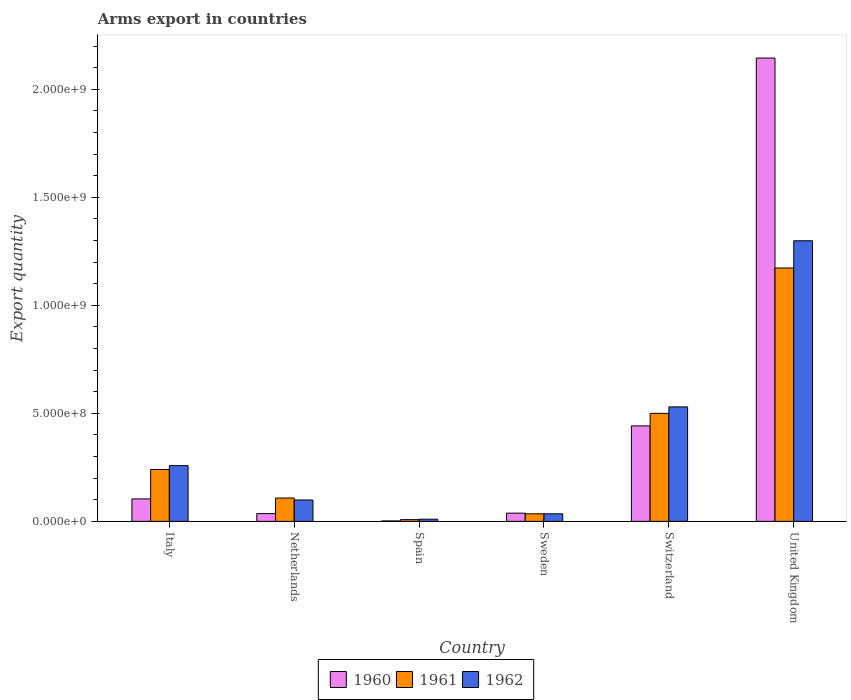How many different coloured bars are there?
Your answer should be very brief. 3. Are the number of bars per tick equal to the number of legend labels?
Offer a terse response. Yes. How many bars are there on the 3rd tick from the left?
Make the answer very short. 3. In how many cases, is the number of bars for a given country not equal to the number of legend labels?
Keep it short and to the point. 0. Across all countries, what is the maximum total arms export in 1960?
Your response must be concise. 2.14e+09. Across all countries, what is the minimum total arms export in 1960?
Keep it short and to the point. 2.00e+06. What is the total total arms export in 1961 in the graph?
Your answer should be very brief. 2.06e+09. What is the difference between the total arms export in 1962 in Netherlands and that in United Kingdom?
Your answer should be compact. -1.20e+09. What is the difference between the total arms export in 1961 in Netherlands and the total arms export in 1960 in Switzerland?
Make the answer very short. -3.34e+08. What is the average total arms export in 1962 per country?
Your response must be concise. 3.72e+08. What is the difference between the total arms export of/in 1960 and total arms export of/in 1961 in Italy?
Your answer should be very brief. -1.36e+08. What is the ratio of the total arms export in 1962 in Italy to that in Spain?
Your answer should be very brief. 25.8. Is the difference between the total arms export in 1960 in Netherlands and United Kingdom greater than the difference between the total arms export in 1961 in Netherlands and United Kingdom?
Your answer should be very brief. No. What is the difference between the highest and the second highest total arms export in 1962?
Your answer should be compact. 1.04e+09. What is the difference between the highest and the lowest total arms export in 1961?
Your answer should be compact. 1.16e+09. In how many countries, is the total arms export in 1960 greater than the average total arms export in 1960 taken over all countries?
Your response must be concise. 1. What does the 2nd bar from the left in Sweden represents?
Make the answer very short. 1961. Are all the bars in the graph horizontal?
Offer a terse response. No. What is the difference between two consecutive major ticks on the Y-axis?
Keep it short and to the point. 5.00e+08. Does the graph contain any zero values?
Keep it short and to the point. No. How many legend labels are there?
Ensure brevity in your answer.  3. How are the legend labels stacked?
Your response must be concise. Horizontal. What is the title of the graph?
Provide a succinct answer. Arms export in countries. What is the label or title of the X-axis?
Make the answer very short. Country. What is the label or title of the Y-axis?
Make the answer very short. Export quantity. What is the Export quantity of 1960 in Italy?
Provide a succinct answer. 1.04e+08. What is the Export quantity in 1961 in Italy?
Provide a short and direct response. 2.40e+08. What is the Export quantity of 1962 in Italy?
Make the answer very short. 2.58e+08. What is the Export quantity in 1960 in Netherlands?
Provide a short and direct response. 3.60e+07. What is the Export quantity of 1961 in Netherlands?
Your answer should be very brief. 1.08e+08. What is the Export quantity in 1962 in Netherlands?
Your response must be concise. 9.90e+07. What is the Export quantity of 1960 in Spain?
Give a very brief answer. 2.00e+06. What is the Export quantity in 1961 in Spain?
Give a very brief answer. 8.00e+06. What is the Export quantity of 1960 in Sweden?
Your response must be concise. 3.80e+07. What is the Export quantity in 1961 in Sweden?
Provide a short and direct response. 3.50e+07. What is the Export quantity in 1962 in Sweden?
Your response must be concise. 3.50e+07. What is the Export quantity of 1960 in Switzerland?
Your response must be concise. 4.42e+08. What is the Export quantity of 1962 in Switzerland?
Provide a succinct answer. 5.30e+08. What is the Export quantity in 1960 in United Kingdom?
Make the answer very short. 2.14e+09. What is the Export quantity of 1961 in United Kingdom?
Keep it short and to the point. 1.17e+09. What is the Export quantity in 1962 in United Kingdom?
Give a very brief answer. 1.30e+09. Across all countries, what is the maximum Export quantity in 1960?
Your answer should be compact. 2.14e+09. Across all countries, what is the maximum Export quantity of 1961?
Your answer should be very brief. 1.17e+09. Across all countries, what is the maximum Export quantity of 1962?
Provide a succinct answer. 1.30e+09. Across all countries, what is the minimum Export quantity in 1961?
Offer a terse response. 8.00e+06. What is the total Export quantity of 1960 in the graph?
Ensure brevity in your answer.  2.77e+09. What is the total Export quantity in 1961 in the graph?
Your answer should be very brief. 2.06e+09. What is the total Export quantity of 1962 in the graph?
Offer a very short reply. 2.23e+09. What is the difference between the Export quantity in 1960 in Italy and that in Netherlands?
Offer a very short reply. 6.80e+07. What is the difference between the Export quantity in 1961 in Italy and that in Netherlands?
Give a very brief answer. 1.32e+08. What is the difference between the Export quantity of 1962 in Italy and that in Netherlands?
Your response must be concise. 1.59e+08. What is the difference between the Export quantity of 1960 in Italy and that in Spain?
Give a very brief answer. 1.02e+08. What is the difference between the Export quantity in 1961 in Italy and that in Spain?
Provide a succinct answer. 2.32e+08. What is the difference between the Export quantity in 1962 in Italy and that in Spain?
Give a very brief answer. 2.48e+08. What is the difference between the Export quantity of 1960 in Italy and that in Sweden?
Keep it short and to the point. 6.60e+07. What is the difference between the Export quantity in 1961 in Italy and that in Sweden?
Your response must be concise. 2.05e+08. What is the difference between the Export quantity in 1962 in Italy and that in Sweden?
Your answer should be compact. 2.23e+08. What is the difference between the Export quantity in 1960 in Italy and that in Switzerland?
Your response must be concise. -3.38e+08. What is the difference between the Export quantity in 1961 in Italy and that in Switzerland?
Make the answer very short. -2.60e+08. What is the difference between the Export quantity of 1962 in Italy and that in Switzerland?
Ensure brevity in your answer.  -2.72e+08. What is the difference between the Export quantity in 1960 in Italy and that in United Kingdom?
Provide a short and direct response. -2.04e+09. What is the difference between the Export quantity of 1961 in Italy and that in United Kingdom?
Your answer should be very brief. -9.33e+08. What is the difference between the Export quantity of 1962 in Italy and that in United Kingdom?
Give a very brief answer. -1.04e+09. What is the difference between the Export quantity in 1960 in Netherlands and that in Spain?
Keep it short and to the point. 3.40e+07. What is the difference between the Export quantity of 1962 in Netherlands and that in Spain?
Offer a terse response. 8.90e+07. What is the difference between the Export quantity of 1960 in Netherlands and that in Sweden?
Your answer should be very brief. -2.00e+06. What is the difference between the Export quantity in 1961 in Netherlands and that in Sweden?
Your answer should be very brief. 7.30e+07. What is the difference between the Export quantity of 1962 in Netherlands and that in Sweden?
Make the answer very short. 6.40e+07. What is the difference between the Export quantity of 1960 in Netherlands and that in Switzerland?
Give a very brief answer. -4.06e+08. What is the difference between the Export quantity in 1961 in Netherlands and that in Switzerland?
Your answer should be compact. -3.92e+08. What is the difference between the Export quantity in 1962 in Netherlands and that in Switzerland?
Give a very brief answer. -4.31e+08. What is the difference between the Export quantity in 1960 in Netherlands and that in United Kingdom?
Provide a succinct answer. -2.11e+09. What is the difference between the Export quantity in 1961 in Netherlands and that in United Kingdom?
Offer a very short reply. -1.06e+09. What is the difference between the Export quantity of 1962 in Netherlands and that in United Kingdom?
Make the answer very short. -1.20e+09. What is the difference between the Export quantity of 1960 in Spain and that in Sweden?
Give a very brief answer. -3.60e+07. What is the difference between the Export quantity in 1961 in Spain and that in Sweden?
Make the answer very short. -2.70e+07. What is the difference between the Export quantity in 1962 in Spain and that in Sweden?
Your answer should be compact. -2.50e+07. What is the difference between the Export quantity of 1960 in Spain and that in Switzerland?
Offer a terse response. -4.40e+08. What is the difference between the Export quantity of 1961 in Spain and that in Switzerland?
Offer a very short reply. -4.92e+08. What is the difference between the Export quantity of 1962 in Spain and that in Switzerland?
Make the answer very short. -5.20e+08. What is the difference between the Export quantity of 1960 in Spain and that in United Kingdom?
Your answer should be very brief. -2.14e+09. What is the difference between the Export quantity in 1961 in Spain and that in United Kingdom?
Your answer should be compact. -1.16e+09. What is the difference between the Export quantity in 1962 in Spain and that in United Kingdom?
Offer a terse response. -1.29e+09. What is the difference between the Export quantity of 1960 in Sweden and that in Switzerland?
Give a very brief answer. -4.04e+08. What is the difference between the Export quantity in 1961 in Sweden and that in Switzerland?
Ensure brevity in your answer.  -4.65e+08. What is the difference between the Export quantity of 1962 in Sweden and that in Switzerland?
Your response must be concise. -4.95e+08. What is the difference between the Export quantity of 1960 in Sweden and that in United Kingdom?
Offer a very short reply. -2.11e+09. What is the difference between the Export quantity of 1961 in Sweden and that in United Kingdom?
Offer a very short reply. -1.14e+09. What is the difference between the Export quantity of 1962 in Sweden and that in United Kingdom?
Your answer should be compact. -1.26e+09. What is the difference between the Export quantity in 1960 in Switzerland and that in United Kingdom?
Make the answer very short. -1.70e+09. What is the difference between the Export quantity in 1961 in Switzerland and that in United Kingdom?
Offer a very short reply. -6.73e+08. What is the difference between the Export quantity in 1962 in Switzerland and that in United Kingdom?
Ensure brevity in your answer.  -7.69e+08. What is the difference between the Export quantity in 1960 in Italy and the Export quantity in 1962 in Netherlands?
Make the answer very short. 5.00e+06. What is the difference between the Export quantity in 1961 in Italy and the Export quantity in 1962 in Netherlands?
Ensure brevity in your answer.  1.41e+08. What is the difference between the Export quantity in 1960 in Italy and the Export quantity in 1961 in Spain?
Ensure brevity in your answer.  9.60e+07. What is the difference between the Export quantity of 1960 in Italy and the Export quantity of 1962 in Spain?
Offer a very short reply. 9.40e+07. What is the difference between the Export quantity of 1961 in Italy and the Export quantity of 1962 in Spain?
Provide a short and direct response. 2.30e+08. What is the difference between the Export quantity in 1960 in Italy and the Export quantity in 1961 in Sweden?
Provide a short and direct response. 6.90e+07. What is the difference between the Export quantity of 1960 in Italy and the Export quantity of 1962 in Sweden?
Your answer should be compact. 6.90e+07. What is the difference between the Export quantity of 1961 in Italy and the Export quantity of 1962 in Sweden?
Your answer should be compact. 2.05e+08. What is the difference between the Export quantity in 1960 in Italy and the Export quantity in 1961 in Switzerland?
Ensure brevity in your answer.  -3.96e+08. What is the difference between the Export quantity in 1960 in Italy and the Export quantity in 1962 in Switzerland?
Offer a terse response. -4.26e+08. What is the difference between the Export quantity in 1961 in Italy and the Export quantity in 1962 in Switzerland?
Offer a very short reply. -2.90e+08. What is the difference between the Export quantity in 1960 in Italy and the Export quantity in 1961 in United Kingdom?
Ensure brevity in your answer.  -1.07e+09. What is the difference between the Export quantity of 1960 in Italy and the Export quantity of 1962 in United Kingdom?
Provide a succinct answer. -1.20e+09. What is the difference between the Export quantity in 1961 in Italy and the Export quantity in 1962 in United Kingdom?
Offer a very short reply. -1.06e+09. What is the difference between the Export quantity of 1960 in Netherlands and the Export quantity of 1961 in Spain?
Keep it short and to the point. 2.80e+07. What is the difference between the Export quantity in 1960 in Netherlands and the Export quantity in 1962 in Spain?
Your response must be concise. 2.60e+07. What is the difference between the Export quantity in 1961 in Netherlands and the Export quantity in 1962 in Spain?
Ensure brevity in your answer.  9.80e+07. What is the difference between the Export quantity of 1960 in Netherlands and the Export quantity of 1962 in Sweden?
Ensure brevity in your answer.  1.00e+06. What is the difference between the Export quantity in 1961 in Netherlands and the Export quantity in 1962 in Sweden?
Provide a succinct answer. 7.30e+07. What is the difference between the Export quantity of 1960 in Netherlands and the Export quantity of 1961 in Switzerland?
Your response must be concise. -4.64e+08. What is the difference between the Export quantity of 1960 in Netherlands and the Export quantity of 1962 in Switzerland?
Ensure brevity in your answer.  -4.94e+08. What is the difference between the Export quantity of 1961 in Netherlands and the Export quantity of 1962 in Switzerland?
Ensure brevity in your answer.  -4.22e+08. What is the difference between the Export quantity of 1960 in Netherlands and the Export quantity of 1961 in United Kingdom?
Your answer should be very brief. -1.14e+09. What is the difference between the Export quantity in 1960 in Netherlands and the Export quantity in 1962 in United Kingdom?
Make the answer very short. -1.26e+09. What is the difference between the Export quantity in 1961 in Netherlands and the Export quantity in 1962 in United Kingdom?
Ensure brevity in your answer.  -1.19e+09. What is the difference between the Export quantity of 1960 in Spain and the Export quantity of 1961 in Sweden?
Your answer should be compact. -3.30e+07. What is the difference between the Export quantity in 1960 in Spain and the Export quantity in 1962 in Sweden?
Make the answer very short. -3.30e+07. What is the difference between the Export quantity in 1961 in Spain and the Export quantity in 1962 in Sweden?
Make the answer very short. -2.70e+07. What is the difference between the Export quantity in 1960 in Spain and the Export quantity in 1961 in Switzerland?
Make the answer very short. -4.98e+08. What is the difference between the Export quantity in 1960 in Spain and the Export quantity in 1962 in Switzerland?
Provide a succinct answer. -5.28e+08. What is the difference between the Export quantity in 1961 in Spain and the Export quantity in 1962 in Switzerland?
Ensure brevity in your answer.  -5.22e+08. What is the difference between the Export quantity in 1960 in Spain and the Export quantity in 1961 in United Kingdom?
Keep it short and to the point. -1.17e+09. What is the difference between the Export quantity of 1960 in Spain and the Export quantity of 1962 in United Kingdom?
Keep it short and to the point. -1.30e+09. What is the difference between the Export quantity in 1961 in Spain and the Export quantity in 1962 in United Kingdom?
Keep it short and to the point. -1.29e+09. What is the difference between the Export quantity of 1960 in Sweden and the Export quantity of 1961 in Switzerland?
Offer a very short reply. -4.62e+08. What is the difference between the Export quantity of 1960 in Sweden and the Export quantity of 1962 in Switzerland?
Your answer should be very brief. -4.92e+08. What is the difference between the Export quantity of 1961 in Sweden and the Export quantity of 1962 in Switzerland?
Make the answer very short. -4.95e+08. What is the difference between the Export quantity of 1960 in Sweden and the Export quantity of 1961 in United Kingdom?
Give a very brief answer. -1.14e+09. What is the difference between the Export quantity in 1960 in Sweden and the Export quantity in 1962 in United Kingdom?
Offer a very short reply. -1.26e+09. What is the difference between the Export quantity of 1961 in Sweden and the Export quantity of 1962 in United Kingdom?
Provide a short and direct response. -1.26e+09. What is the difference between the Export quantity in 1960 in Switzerland and the Export quantity in 1961 in United Kingdom?
Offer a very short reply. -7.31e+08. What is the difference between the Export quantity of 1960 in Switzerland and the Export quantity of 1962 in United Kingdom?
Keep it short and to the point. -8.57e+08. What is the difference between the Export quantity of 1961 in Switzerland and the Export quantity of 1962 in United Kingdom?
Give a very brief answer. -7.99e+08. What is the average Export quantity in 1960 per country?
Your answer should be compact. 4.61e+08. What is the average Export quantity of 1961 per country?
Make the answer very short. 3.44e+08. What is the average Export quantity in 1962 per country?
Your response must be concise. 3.72e+08. What is the difference between the Export quantity of 1960 and Export quantity of 1961 in Italy?
Keep it short and to the point. -1.36e+08. What is the difference between the Export quantity in 1960 and Export quantity in 1962 in Italy?
Give a very brief answer. -1.54e+08. What is the difference between the Export quantity of 1961 and Export quantity of 1962 in Italy?
Keep it short and to the point. -1.80e+07. What is the difference between the Export quantity in 1960 and Export quantity in 1961 in Netherlands?
Ensure brevity in your answer.  -7.20e+07. What is the difference between the Export quantity in 1960 and Export quantity in 1962 in Netherlands?
Offer a very short reply. -6.30e+07. What is the difference between the Export quantity of 1961 and Export quantity of 1962 in Netherlands?
Make the answer very short. 9.00e+06. What is the difference between the Export quantity of 1960 and Export quantity of 1961 in Spain?
Provide a short and direct response. -6.00e+06. What is the difference between the Export quantity in 1960 and Export quantity in 1962 in Spain?
Offer a terse response. -8.00e+06. What is the difference between the Export quantity in 1961 and Export quantity in 1962 in Spain?
Offer a terse response. -2.00e+06. What is the difference between the Export quantity in 1960 and Export quantity in 1961 in Sweden?
Ensure brevity in your answer.  3.00e+06. What is the difference between the Export quantity in 1961 and Export quantity in 1962 in Sweden?
Your response must be concise. 0. What is the difference between the Export quantity of 1960 and Export quantity of 1961 in Switzerland?
Ensure brevity in your answer.  -5.80e+07. What is the difference between the Export quantity in 1960 and Export quantity in 1962 in Switzerland?
Your response must be concise. -8.80e+07. What is the difference between the Export quantity of 1961 and Export quantity of 1962 in Switzerland?
Your answer should be very brief. -3.00e+07. What is the difference between the Export quantity in 1960 and Export quantity in 1961 in United Kingdom?
Your answer should be very brief. 9.72e+08. What is the difference between the Export quantity in 1960 and Export quantity in 1962 in United Kingdom?
Provide a short and direct response. 8.46e+08. What is the difference between the Export quantity of 1961 and Export quantity of 1962 in United Kingdom?
Offer a very short reply. -1.26e+08. What is the ratio of the Export quantity of 1960 in Italy to that in Netherlands?
Offer a very short reply. 2.89. What is the ratio of the Export quantity in 1961 in Italy to that in Netherlands?
Your answer should be very brief. 2.22. What is the ratio of the Export quantity in 1962 in Italy to that in Netherlands?
Keep it short and to the point. 2.61. What is the ratio of the Export quantity of 1960 in Italy to that in Spain?
Ensure brevity in your answer.  52. What is the ratio of the Export quantity in 1962 in Italy to that in Spain?
Provide a succinct answer. 25.8. What is the ratio of the Export quantity in 1960 in Italy to that in Sweden?
Make the answer very short. 2.74. What is the ratio of the Export quantity in 1961 in Italy to that in Sweden?
Provide a short and direct response. 6.86. What is the ratio of the Export quantity of 1962 in Italy to that in Sweden?
Offer a very short reply. 7.37. What is the ratio of the Export quantity of 1960 in Italy to that in Switzerland?
Make the answer very short. 0.24. What is the ratio of the Export quantity in 1961 in Italy to that in Switzerland?
Your answer should be very brief. 0.48. What is the ratio of the Export quantity in 1962 in Italy to that in Switzerland?
Offer a terse response. 0.49. What is the ratio of the Export quantity of 1960 in Italy to that in United Kingdom?
Offer a very short reply. 0.05. What is the ratio of the Export quantity of 1961 in Italy to that in United Kingdom?
Your answer should be very brief. 0.2. What is the ratio of the Export quantity in 1962 in Italy to that in United Kingdom?
Provide a succinct answer. 0.2. What is the ratio of the Export quantity of 1961 in Netherlands to that in Spain?
Give a very brief answer. 13.5. What is the ratio of the Export quantity in 1960 in Netherlands to that in Sweden?
Provide a short and direct response. 0.95. What is the ratio of the Export quantity of 1961 in Netherlands to that in Sweden?
Your response must be concise. 3.09. What is the ratio of the Export quantity of 1962 in Netherlands to that in Sweden?
Make the answer very short. 2.83. What is the ratio of the Export quantity in 1960 in Netherlands to that in Switzerland?
Provide a short and direct response. 0.08. What is the ratio of the Export quantity of 1961 in Netherlands to that in Switzerland?
Keep it short and to the point. 0.22. What is the ratio of the Export quantity in 1962 in Netherlands to that in Switzerland?
Provide a short and direct response. 0.19. What is the ratio of the Export quantity of 1960 in Netherlands to that in United Kingdom?
Your answer should be very brief. 0.02. What is the ratio of the Export quantity of 1961 in Netherlands to that in United Kingdom?
Offer a very short reply. 0.09. What is the ratio of the Export quantity in 1962 in Netherlands to that in United Kingdom?
Your answer should be compact. 0.08. What is the ratio of the Export quantity in 1960 in Spain to that in Sweden?
Your response must be concise. 0.05. What is the ratio of the Export quantity in 1961 in Spain to that in Sweden?
Keep it short and to the point. 0.23. What is the ratio of the Export quantity in 1962 in Spain to that in Sweden?
Your response must be concise. 0.29. What is the ratio of the Export quantity in 1960 in Spain to that in Switzerland?
Your response must be concise. 0. What is the ratio of the Export quantity of 1961 in Spain to that in Switzerland?
Make the answer very short. 0.02. What is the ratio of the Export quantity in 1962 in Spain to that in Switzerland?
Keep it short and to the point. 0.02. What is the ratio of the Export quantity in 1960 in Spain to that in United Kingdom?
Offer a terse response. 0. What is the ratio of the Export quantity of 1961 in Spain to that in United Kingdom?
Ensure brevity in your answer.  0.01. What is the ratio of the Export quantity of 1962 in Spain to that in United Kingdom?
Keep it short and to the point. 0.01. What is the ratio of the Export quantity of 1960 in Sweden to that in Switzerland?
Provide a short and direct response. 0.09. What is the ratio of the Export quantity of 1961 in Sweden to that in Switzerland?
Your answer should be very brief. 0.07. What is the ratio of the Export quantity of 1962 in Sweden to that in Switzerland?
Keep it short and to the point. 0.07. What is the ratio of the Export quantity in 1960 in Sweden to that in United Kingdom?
Provide a short and direct response. 0.02. What is the ratio of the Export quantity of 1961 in Sweden to that in United Kingdom?
Make the answer very short. 0.03. What is the ratio of the Export quantity in 1962 in Sweden to that in United Kingdom?
Provide a short and direct response. 0.03. What is the ratio of the Export quantity of 1960 in Switzerland to that in United Kingdom?
Your answer should be very brief. 0.21. What is the ratio of the Export quantity of 1961 in Switzerland to that in United Kingdom?
Provide a succinct answer. 0.43. What is the ratio of the Export quantity of 1962 in Switzerland to that in United Kingdom?
Your answer should be compact. 0.41. What is the difference between the highest and the second highest Export quantity of 1960?
Provide a short and direct response. 1.70e+09. What is the difference between the highest and the second highest Export quantity in 1961?
Offer a terse response. 6.73e+08. What is the difference between the highest and the second highest Export quantity in 1962?
Keep it short and to the point. 7.69e+08. What is the difference between the highest and the lowest Export quantity in 1960?
Offer a terse response. 2.14e+09. What is the difference between the highest and the lowest Export quantity in 1961?
Offer a terse response. 1.16e+09. What is the difference between the highest and the lowest Export quantity in 1962?
Provide a succinct answer. 1.29e+09. 